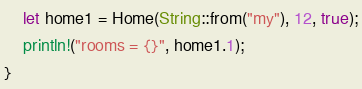<code> <loc_0><loc_0><loc_500><loc_500><_Rust_>	let home1 = Home(String::from("my"), 12, true);
	println!("rooms = {}", home1.1);
}</code> 